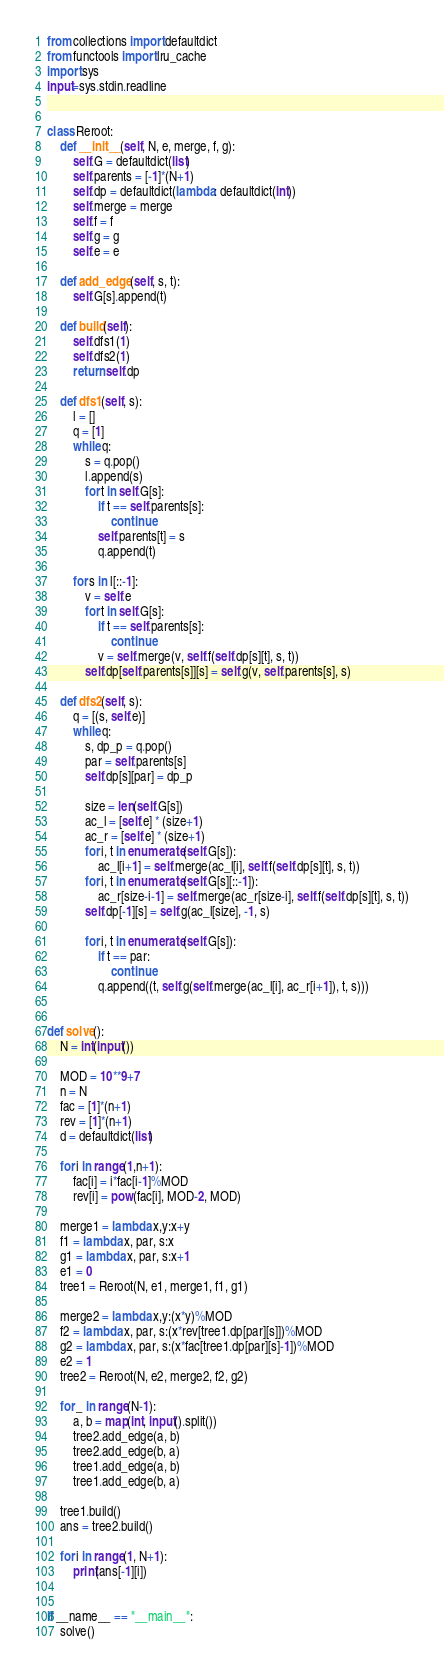<code> <loc_0><loc_0><loc_500><loc_500><_Python_>from collections import defaultdict
from functools import lru_cache
import sys
input=sys.stdin.readline


class Reroot:
    def __init__(self, N, e, merge, f, g):
        self.G = defaultdict(list)
        self.parents = [-1]*(N+1)
        self.dp = defaultdict(lambda: defaultdict(int))
        self.merge = merge
        self.f = f
        self.g = g
        self.e = e

    def add_edge(self, s, t):
        self.G[s].append(t)

    def build(self):
        self.dfs1(1)
        self.dfs2(1)
        return self.dp

    def dfs1(self, s):
        l = []
        q = [1]
        while q:
            s = q.pop()
            l.append(s)
            for t in self.G[s]:
                if t == self.parents[s]:
                    continue
                self.parents[t] = s
                q.append(t)

        for s in l[::-1]:
            v = self.e
            for t in self.G[s]:
                if t == self.parents[s]:
                    continue
                v = self.merge(v, self.f(self.dp[s][t], s, t))
            self.dp[self.parents[s]][s] = self.g(v, self.parents[s], s)

    def dfs2(self, s):
        q = [(s, self.e)]
        while q:
            s, dp_p = q.pop()
            par = self.parents[s]
            self.dp[s][par] = dp_p

            size = len(self.G[s])
            ac_l = [self.e] * (size+1)
            ac_r = [self.e] * (size+1)
            for i, t in enumerate(self.G[s]):
                ac_l[i+1] = self.merge(ac_l[i], self.f(self.dp[s][t], s, t))
            for i, t in enumerate(self.G[s][::-1]):
                ac_r[size-i-1] = self.merge(ac_r[size-i], self.f(self.dp[s][t], s, t))
            self.dp[-1][s] = self.g(ac_l[size], -1, s)

            for i, t in enumerate(self.G[s]):
                if t == par:
                    continue
                q.append((t, self.g(self.merge(ac_l[i], ac_r[i+1]), t, s)))


def solve():
    N = int(input())

    MOD = 10**9+7
    n = N
    fac = [1]*(n+1)
    rev = [1]*(n+1)
    d = defaultdict(list)

    for i in range(1,n+1):
        fac[i] = i*fac[i-1]%MOD
        rev[i] = pow(fac[i], MOD-2, MOD)

    merge1 = lambda x,y:x+y
    f1 = lambda x, par, s:x
    g1 = lambda x, par, s:x+1
    e1 = 0
    tree1 = Reroot(N, e1, merge1, f1, g1)

    merge2 = lambda x,y:(x*y)%MOD
    f2 = lambda x, par, s:(x*rev[tree1.dp[par][s]])%MOD
    g2 = lambda x, par, s:(x*fac[tree1.dp[par][s]-1])%MOD
    e2 = 1
    tree2 = Reroot(N, e2, merge2, f2, g2)

    for _ in range(N-1):
        a, b = map(int, input().split())
        tree2.add_edge(a, b)
        tree2.add_edge(b, a)
        tree1.add_edge(a, b)
        tree1.add_edge(b, a)

    tree1.build()
    ans = tree2.build()

    for i in range(1, N+1):
        print(ans[-1][i])


if __name__ == "__main__":
    solve()
</code> 